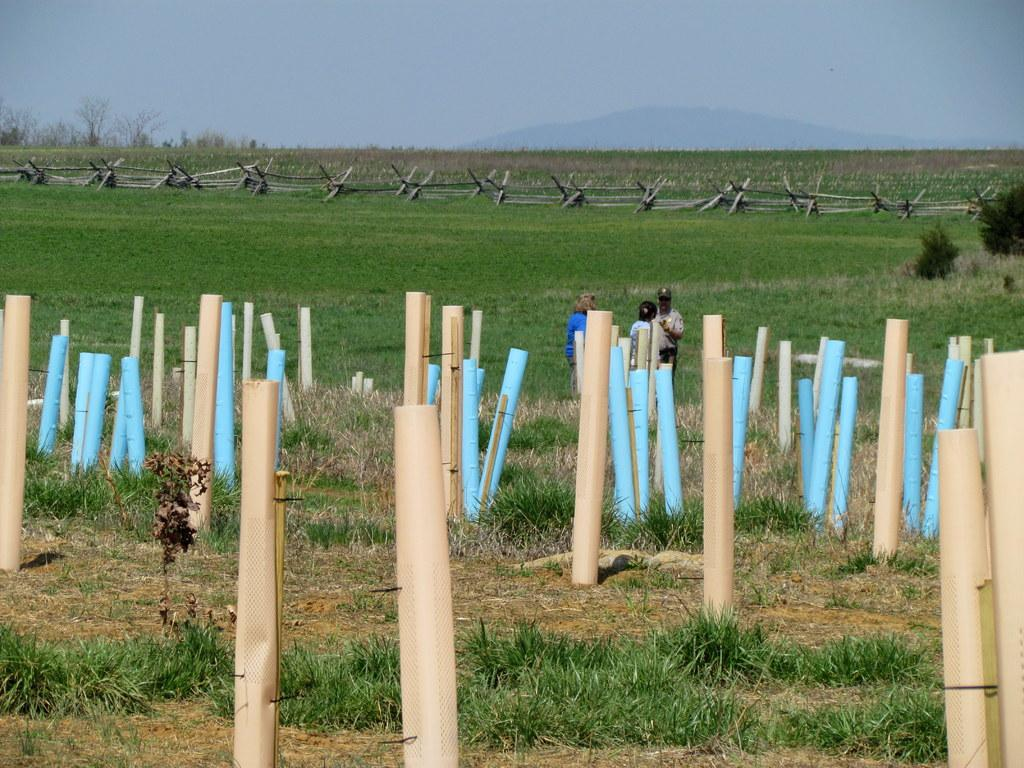What colors are the poles in the image? The poles in the image are cream and blue. What type of terrain is visible in the image? There is grass visible in the image. Can you describe the people in the image? There are people standing in the image. What can be seen in the background of the image? The background of the image includes trees, a hill, and the sky. What type of vessel is being used by the cook in the image? There is no cook or vessel present in the image. 